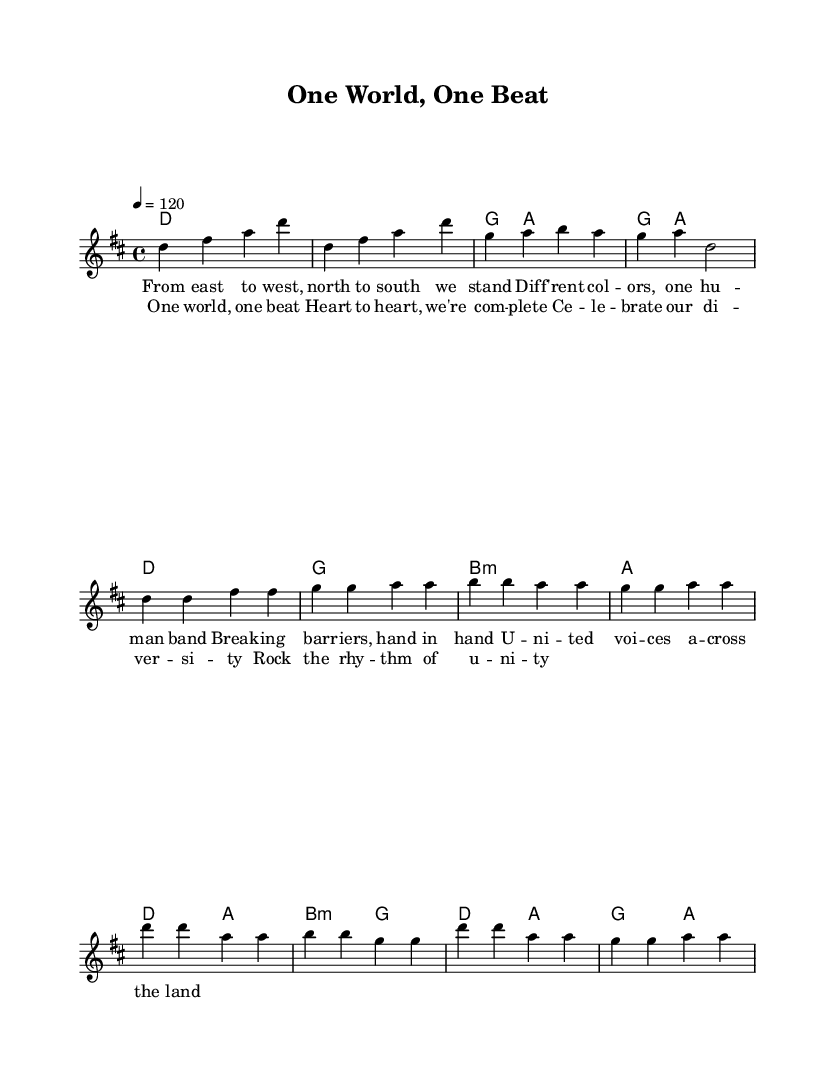What is the key signature of this music? The key signature is indicated at the beginning of the staff in the global section, which shows that it is D major, having two sharps (F# and C#).
Answer: D major What is the time signature of this piece? The time signature is seen right after the key signature in the global section. It is written as 4/4, meaning there are four beats per measure.
Answer: 4/4 What is the tempo marking of the song? The tempo marking is found in the global section, stating "4 = 120," indicating that there are 120 quarter note beats per minute.
Answer: 120 How many measures are in the verse section? In the provided melody, the verse consists of 4 measures as indicated by the notes grouped within the verse section.
Answer: 4 What chord follows the D major chord in the verse? In the chord section of the verse, after the D major chord, the next chord is G major, which is indicated in the chord mode.
Answer: G What lyrical theme does the chorus emphasize? The chorus emphasizes unity and celebration of cultural diversity through the lyrics, which speak of "one world, one beat" and "rhythm of unity."
Answer: Unity Which musical element is repeated in the chorus? In the chorus, the element that is repeated is the phrase structure, particularly the rhythm and the words "one" and "beat," which are part of the thematic message.
Answer: Rhythm and theme 